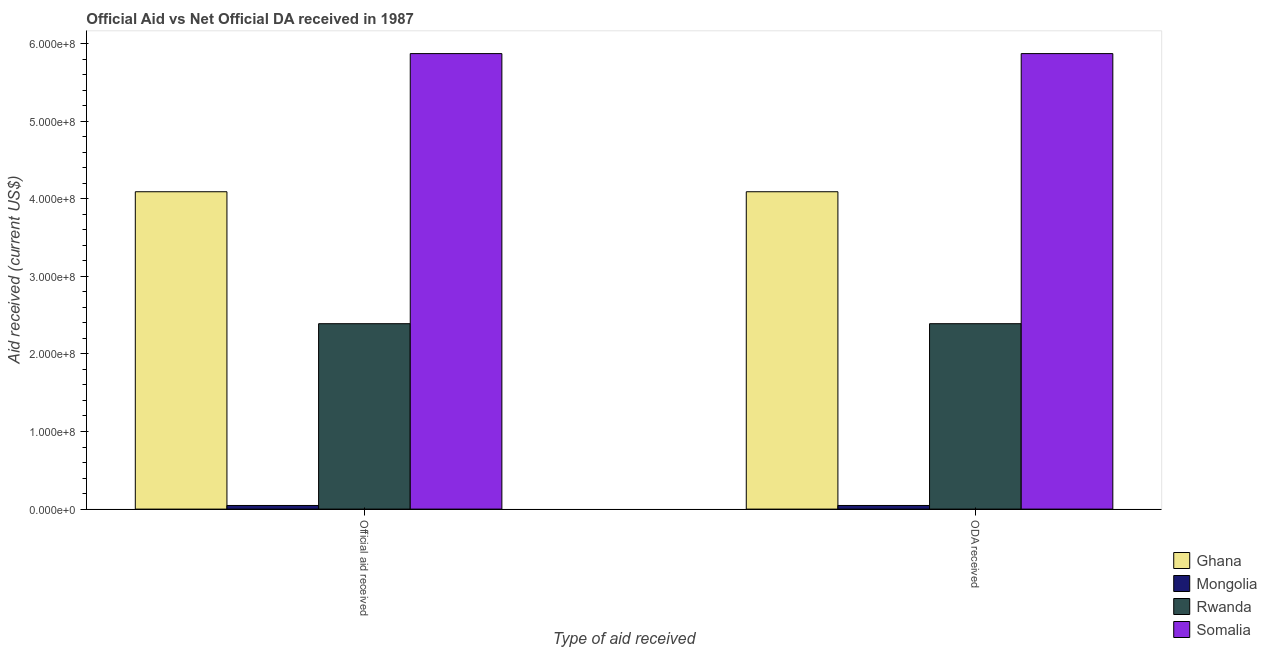How many groups of bars are there?
Offer a very short reply. 2. Are the number of bars per tick equal to the number of legend labels?
Your response must be concise. Yes. Are the number of bars on each tick of the X-axis equal?
Ensure brevity in your answer.  Yes. How many bars are there on the 1st tick from the right?
Your response must be concise. 4. What is the label of the 2nd group of bars from the left?
Your answer should be very brief. ODA received. What is the oda received in Somalia?
Give a very brief answer. 5.87e+08. Across all countries, what is the maximum official aid received?
Offer a very short reply. 5.87e+08. Across all countries, what is the minimum oda received?
Ensure brevity in your answer.  4.68e+06. In which country was the oda received maximum?
Your answer should be very brief. Somalia. In which country was the oda received minimum?
Offer a terse response. Mongolia. What is the total oda received in the graph?
Your answer should be compact. 1.24e+09. What is the difference between the oda received in Mongolia and that in Ghana?
Give a very brief answer. -4.04e+08. What is the difference between the oda received in Somalia and the official aid received in Ghana?
Offer a terse response. 1.78e+08. What is the average official aid received per country?
Make the answer very short. 3.10e+08. What is the ratio of the official aid received in Rwanda to that in Somalia?
Provide a short and direct response. 0.41. Is the oda received in Ghana less than that in Mongolia?
Your answer should be compact. No. In how many countries, is the official aid received greater than the average official aid received taken over all countries?
Your answer should be compact. 2. What does the 4th bar from the left in Official aid received represents?
Provide a short and direct response. Somalia. What does the 2nd bar from the right in Official aid received represents?
Offer a very short reply. Rwanda. How many bars are there?
Keep it short and to the point. 8. Are all the bars in the graph horizontal?
Your response must be concise. No. How many countries are there in the graph?
Make the answer very short. 4. Are the values on the major ticks of Y-axis written in scientific E-notation?
Your answer should be very brief. Yes. Does the graph contain any zero values?
Your answer should be compact. No. How are the legend labels stacked?
Your answer should be very brief. Vertical. What is the title of the graph?
Provide a short and direct response. Official Aid vs Net Official DA received in 1987 . Does "Grenada" appear as one of the legend labels in the graph?
Keep it short and to the point. No. What is the label or title of the X-axis?
Keep it short and to the point. Type of aid received. What is the label or title of the Y-axis?
Provide a succinct answer. Aid received (current US$). What is the Aid received (current US$) in Ghana in Official aid received?
Your answer should be compact. 4.09e+08. What is the Aid received (current US$) in Mongolia in Official aid received?
Your answer should be compact. 4.68e+06. What is the Aid received (current US$) of Rwanda in Official aid received?
Ensure brevity in your answer.  2.39e+08. What is the Aid received (current US$) in Somalia in Official aid received?
Make the answer very short. 5.87e+08. What is the Aid received (current US$) of Ghana in ODA received?
Give a very brief answer. 4.09e+08. What is the Aid received (current US$) of Mongolia in ODA received?
Provide a short and direct response. 4.68e+06. What is the Aid received (current US$) of Rwanda in ODA received?
Offer a terse response. 2.39e+08. What is the Aid received (current US$) of Somalia in ODA received?
Make the answer very short. 5.87e+08. Across all Type of aid received, what is the maximum Aid received (current US$) in Ghana?
Your response must be concise. 4.09e+08. Across all Type of aid received, what is the maximum Aid received (current US$) of Mongolia?
Offer a terse response. 4.68e+06. Across all Type of aid received, what is the maximum Aid received (current US$) of Rwanda?
Give a very brief answer. 2.39e+08. Across all Type of aid received, what is the maximum Aid received (current US$) of Somalia?
Your answer should be very brief. 5.87e+08. Across all Type of aid received, what is the minimum Aid received (current US$) in Ghana?
Your answer should be very brief. 4.09e+08. Across all Type of aid received, what is the minimum Aid received (current US$) in Mongolia?
Give a very brief answer. 4.68e+06. Across all Type of aid received, what is the minimum Aid received (current US$) in Rwanda?
Ensure brevity in your answer.  2.39e+08. Across all Type of aid received, what is the minimum Aid received (current US$) in Somalia?
Offer a very short reply. 5.87e+08. What is the total Aid received (current US$) of Ghana in the graph?
Your answer should be compact. 8.18e+08. What is the total Aid received (current US$) of Mongolia in the graph?
Offer a very short reply. 9.36e+06. What is the total Aid received (current US$) in Rwanda in the graph?
Offer a terse response. 4.78e+08. What is the total Aid received (current US$) of Somalia in the graph?
Provide a succinct answer. 1.17e+09. What is the difference between the Aid received (current US$) in Mongolia in Official aid received and that in ODA received?
Keep it short and to the point. 0. What is the difference between the Aid received (current US$) of Rwanda in Official aid received and that in ODA received?
Provide a short and direct response. 0. What is the difference between the Aid received (current US$) of Ghana in Official aid received and the Aid received (current US$) of Mongolia in ODA received?
Keep it short and to the point. 4.04e+08. What is the difference between the Aid received (current US$) of Ghana in Official aid received and the Aid received (current US$) of Rwanda in ODA received?
Keep it short and to the point. 1.70e+08. What is the difference between the Aid received (current US$) in Ghana in Official aid received and the Aid received (current US$) in Somalia in ODA received?
Make the answer very short. -1.78e+08. What is the difference between the Aid received (current US$) in Mongolia in Official aid received and the Aid received (current US$) in Rwanda in ODA received?
Offer a terse response. -2.34e+08. What is the difference between the Aid received (current US$) of Mongolia in Official aid received and the Aid received (current US$) of Somalia in ODA received?
Provide a succinct answer. -5.82e+08. What is the difference between the Aid received (current US$) in Rwanda in Official aid received and the Aid received (current US$) in Somalia in ODA received?
Your answer should be compact. -3.48e+08. What is the average Aid received (current US$) in Ghana per Type of aid received?
Provide a succinct answer. 4.09e+08. What is the average Aid received (current US$) in Mongolia per Type of aid received?
Your response must be concise. 4.68e+06. What is the average Aid received (current US$) in Rwanda per Type of aid received?
Keep it short and to the point. 2.39e+08. What is the average Aid received (current US$) in Somalia per Type of aid received?
Keep it short and to the point. 5.87e+08. What is the difference between the Aid received (current US$) in Ghana and Aid received (current US$) in Mongolia in Official aid received?
Ensure brevity in your answer.  4.04e+08. What is the difference between the Aid received (current US$) of Ghana and Aid received (current US$) of Rwanda in Official aid received?
Provide a short and direct response. 1.70e+08. What is the difference between the Aid received (current US$) in Ghana and Aid received (current US$) in Somalia in Official aid received?
Make the answer very short. -1.78e+08. What is the difference between the Aid received (current US$) in Mongolia and Aid received (current US$) in Rwanda in Official aid received?
Ensure brevity in your answer.  -2.34e+08. What is the difference between the Aid received (current US$) of Mongolia and Aid received (current US$) of Somalia in Official aid received?
Keep it short and to the point. -5.82e+08. What is the difference between the Aid received (current US$) of Rwanda and Aid received (current US$) of Somalia in Official aid received?
Provide a short and direct response. -3.48e+08. What is the difference between the Aid received (current US$) of Ghana and Aid received (current US$) of Mongolia in ODA received?
Give a very brief answer. 4.04e+08. What is the difference between the Aid received (current US$) in Ghana and Aid received (current US$) in Rwanda in ODA received?
Offer a very short reply. 1.70e+08. What is the difference between the Aid received (current US$) in Ghana and Aid received (current US$) in Somalia in ODA received?
Give a very brief answer. -1.78e+08. What is the difference between the Aid received (current US$) in Mongolia and Aid received (current US$) in Rwanda in ODA received?
Keep it short and to the point. -2.34e+08. What is the difference between the Aid received (current US$) in Mongolia and Aid received (current US$) in Somalia in ODA received?
Provide a succinct answer. -5.82e+08. What is the difference between the Aid received (current US$) in Rwanda and Aid received (current US$) in Somalia in ODA received?
Offer a very short reply. -3.48e+08. What is the ratio of the Aid received (current US$) in Mongolia in Official aid received to that in ODA received?
Keep it short and to the point. 1. What is the ratio of the Aid received (current US$) in Rwanda in Official aid received to that in ODA received?
Keep it short and to the point. 1. What is the ratio of the Aid received (current US$) of Somalia in Official aid received to that in ODA received?
Make the answer very short. 1. What is the difference between the highest and the second highest Aid received (current US$) of Mongolia?
Your response must be concise. 0. What is the difference between the highest and the second highest Aid received (current US$) in Somalia?
Provide a short and direct response. 0. What is the difference between the highest and the lowest Aid received (current US$) in Ghana?
Offer a terse response. 0. What is the difference between the highest and the lowest Aid received (current US$) of Mongolia?
Keep it short and to the point. 0. What is the difference between the highest and the lowest Aid received (current US$) of Rwanda?
Provide a succinct answer. 0. What is the difference between the highest and the lowest Aid received (current US$) in Somalia?
Give a very brief answer. 0. 